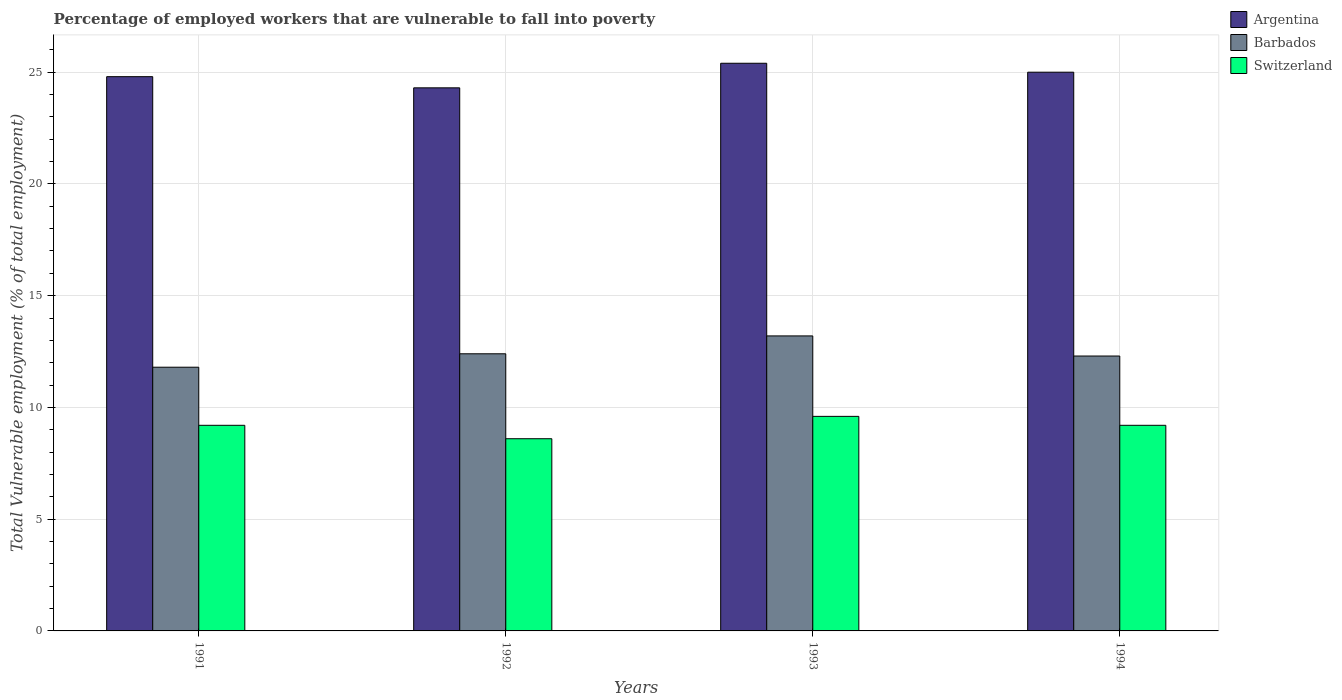How many different coloured bars are there?
Offer a very short reply. 3. Are the number of bars per tick equal to the number of legend labels?
Your response must be concise. Yes. Are the number of bars on each tick of the X-axis equal?
Your answer should be very brief. Yes. How many bars are there on the 3rd tick from the right?
Provide a succinct answer. 3. What is the label of the 2nd group of bars from the left?
Provide a short and direct response. 1992. What is the percentage of employed workers who are vulnerable to fall into poverty in Barbados in 1992?
Your answer should be compact. 12.4. Across all years, what is the maximum percentage of employed workers who are vulnerable to fall into poverty in Barbados?
Your response must be concise. 13.2. Across all years, what is the minimum percentage of employed workers who are vulnerable to fall into poverty in Switzerland?
Keep it short and to the point. 8.6. In which year was the percentage of employed workers who are vulnerable to fall into poverty in Argentina maximum?
Provide a succinct answer. 1993. What is the total percentage of employed workers who are vulnerable to fall into poverty in Argentina in the graph?
Keep it short and to the point. 99.5. What is the difference between the percentage of employed workers who are vulnerable to fall into poverty in Argentina in 1992 and that in 1993?
Your answer should be very brief. -1.1. What is the difference between the percentage of employed workers who are vulnerable to fall into poverty in Barbados in 1993 and the percentage of employed workers who are vulnerable to fall into poverty in Switzerland in 1994?
Provide a succinct answer. 4. What is the average percentage of employed workers who are vulnerable to fall into poverty in Argentina per year?
Your answer should be very brief. 24.87. In the year 1991, what is the difference between the percentage of employed workers who are vulnerable to fall into poverty in Switzerland and percentage of employed workers who are vulnerable to fall into poverty in Barbados?
Make the answer very short. -2.6. In how many years, is the percentage of employed workers who are vulnerable to fall into poverty in Barbados greater than 10 %?
Provide a short and direct response. 4. What is the ratio of the percentage of employed workers who are vulnerable to fall into poverty in Switzerland in 1992 to that in 1994?
Provide a short and direct response. 0.93. Is the percentage of employed workers who are vulnerable to fall into poverty in Switzerland in 1992 less than that in 1993?
Provide a short and direct response. Yes. Is the difference between the percentage of employed workers who are vulnerable to fall into poverty in Switzerland in 1991 and 1994 greater than the difference between the percentage of employed workers who are vulnerable to fall into poverty in Barbados in 1991 and 1994?
Make the answer very short. Yes. What is the difference between the highest and the second highest percentage of employed workers who are vulnerable to fall into poverty in Barbados?
Offer a terse response. 0.8. What is the difference between the highest and the lowest percentage of employed workers who are vulnerable to fall into poverty in Barbados?
Provide a succinct answer. 1.4. In how many years, is the percentage of employed workers who are vulnerable to fall into poverty in Barbados greater than the average percentage of employed workers who are vulnerable to fall into poverty in Barbados taken over all years?
Your response must be concise. 1. What does the 3rd bar from the left in 1993 represents?
Your answer should be compact. Switzerland. What does the 1st bar from the right in 1991 represents?
Your response must be concise. Switzerland. How many bars are there?
Make the answer very short. 12. Are all the bars in the graph horizontal?
Ensure brevity in your answer.  No. Does the graph contain any zero values?
Offer a very short reply. No. How many legend labels are there?
Your answer should be very brief. 3. What is the title of the graph?
Offer a very short reply. Percentage of employed workers that are vulnerable to fall into poverty. Does "Arab World" appear as one of the legend labels in the graph?
Provide a short and direct response. No. What is the label or title of the Y-axis?
Provide a succinct answer. Total Vulnerable employment (% of total employment). What is the Total Vulnerable employment (% of total employment) in Argentina in 1991?
Provide a succinct answer. 24.8. What is the Total Vulnerable employment (% of total employment) in Barbados in 1991?
Your answer should be very brief. 11.8. What is the Total Vulnerable employment (% of total employment) of Switzerland in 1991?
Offer a terse response. 9.2. What is the Total Vulnerable employment (% of total employment) in Argentina in 1992?
Ensure brevity in your answer.  24.3. What is the Total Vulnerable employment (% of total employment) of Barbados in 1992?
Make the answer very short. 12.4. What is the Total Vulnerable employment (% of total employment) of Switzerland in 1992?
Keep it short and to the point. 8.6. What is the Total Vulnerable employment (% of total employment) of Argentina in 1993?
Keep it short and to the point. 25.4. What is the Total Vulnerable employment (% of total employment) of Barbados in 1993?
Give a very brief answer. 13.2. What is the Total Vulnerable employment (% of total employment) in Switzerland in 1993?
Provide a short and direct response. 9.6. What is the Total Vulnerable employment (% of total employment) of Argentina in 1994?
Your answer should be compact. 25. What is the Total Vulnerable employment (% of total employment) of Barbados in 1994?
Your answer should be compact. 12.3. What is the Total Vulnerable employment (% of total employment) in Switzerland in 1994?
Your answer should be very brief. 9.2. Across all years, what is the maximum Total Vulnerable employment (% of total employment) of Argentina?
Your answer should be very brief. 25.4. Across all years, what is the maximum Total Vulnerable employment (% of total employment) of Barbados?
Provide a short and direct response. 13.2. Across all years, what is the maximum Total Vulnerable employment (% of total employment) in Switzerland?
Give a very brief answer. 9.6. Across all years, what is the minimum Total Vulnerable employment (% of total employment) in Argentina?
Your answer should be compact. 24.3. Across all years, what is the minimum Total Vulnerable employment (% of total employment) in Barbados?
Provide a succinct answer. 11.8. Across all years, what is the minimum Total Vulnerable employment (% of total employment) of Switzerland?
Provide a succinct answer. 8.6. What is the total Total Vulnerable employment (% of total employment) of Argentina in the graph?
Provide a short and direct response. 99.5. What is the total Total Vulnerable employment (% of total employment) of Barbados in the graph?
Your response must be concise. 49.7. What is the total Total Vulnerable employment (% of total employment) in Switzerland in the graph?
Provide a short and direct response. 36.6. What is the difference between the Total Vulnerable employment (% of total employment) in Switzerland in 1991 and that in 1992?
Keep it short and to the point. 0.6. What is the difference between the Total Vulnerable employment (% of total employment) in Switzerland in 1991 and that in 1993?
Provide a succinct answer. -0.4. What is the difference between the Total Vulnerable employment (% of total employment) in Argentina in 1991 and that in 1994?
Offer a terse response. -0.2. What is the difference between the Total Vulnerable employment (% of total employment) in Switzerland in 1991 and that in 1994?
Make the answer very short. 0. What is the difference between the Total Vulnerable employment (% of total employment) in Argentina in 1992 and that in 1993?
Your answer should be compact. -1.1. What is the difference between the Total Vulnerable employment (% of total employment) in Barbados in 1992 and that in 1993?
Make the answer very short. -0.8. What is the difference between the Total Vulnerable employment (% of total employment) in Switzerland in 1992 and that in 1993?
Your answer should be very brief. -1. What is the difference between the Total Vulnerable employment (% of total employment) of Barbados in 1992 and that in 1994?
Your answer should be compact. 0.1. What is the difference between the Total Vulnerable employment (% of total employment) in Switzerland in 1993 and that in 1994?
Make the answer very short. 0.4. What is the difference between the Total Vulnerable employment (% of total employment) of Argentina in 1991 and the Total Vulnerable employment (% of total employment) of Barbados in 1993?
Make the answer very short. 11.6. What is the difference between the Total Vulnerable employment (% of total employment) of Barbados in 1991 and the Total Vulnerable employment (% of total employment) of Switzerland in 1993?
Keep it short and to the point. 2.2. What is the difference between the Total Vulnerable employment (% of total employment) in Argentina in 1991 and the Total Vulnerable employment (% of total employment) in Barbados in 1994?
Your response must be concise. 12.5. What is the difference between the Total Vulnerable employment (% of total employment) in Argentina in 1992 and the Total Vulnerable employment (% of total employment) in Barbados in 1993?
Ensure brevity in your answer.  11.1. What is the difference between the Total Vulnerable employment (% of total employment) in Argentina in 1992 and the Total Vulnerable employment (% of total employment) in Switzerland in 1993?
Offer a very short reply. 14.7. What is the difference between the Total Vulnerable employment (% of total employment) in Barbados in 1992 and the Total Vulnerable employment (% of total employment) in Switzerland in 1993?
Keep it short and to the point. 2.8. What is the difference between the Total Vulnerable employment (% of total employment) in Argentina in 1993 and the Total Vulnerable employment (% of total employment) in Barbados in 1994?
Give a very brief answer. 13.1. What is the difference between the Total Vulnerable employment (% of total employment) in Barbados in 1993 and the Total Vulnerable employment (% of total employment) in Switzerland in 1994?
Your answer should be very brief. 4. What is the average Total Vulnerable employment (% of total employment) of Argentina per year?
Your answer should be compact. 24.88. What is the average Total Vulnerable employment (% of total employment) in Barbados per year?
Your answer should be very brief. 12.43. What is the average Total Vulnerable employment (% of total employment) of Switzerland per year?
Provide a succinct answer. 9.15. In the year 1991, what is the difference between the Total Vulnerable employment (% of total employment) in Barbados and Total Vulnerable employment (% of total employment) in Switzerland?
Give a very brief answer. 2.6. What is the ratio of the Total Vulnerable employment (% of total employment) in Argentina in 1991 to that in 1992?
Offer a very short reply. 1.02. What is the ratio of the Total Vulnerable employment (% of total employment) of Barbados in 1991 to that in 1992?
Ensure brevity in your answer.  0.95. What is the ratio of the Total Vulnerable employment (% of total employment) of Switzerland in 1991 to that in 1992?
Your response must be concise. 1.07. What is the ratio of the Total Vulnerable employment (% of total employment) in Argentina in 1991 to that in 1993?
Give a very brief answer. 0.98. What is the ratio of the Total Vulnerable employment (% of total employment) in Barbados in 1991 to that in 1993?
Provide a succinct answer. 0.89. What is the ratio of the Total Vulnerable employment (% of total employment) of Switzerland in 1991 to that in 1993?
Offer a terse response. 0.96. What is the ratio of the Total Vulnerable employment (% of total employment) of Barbados in 1991 to that in 1994?
Keep it short and to the point. 0.96. What is the ratio of the Total Vulnerable employment (% of total employment) of Switzerland in 1991 to that in 1994?
Make the answer very short. 1. What is the ratio of the Total Vulnerable employment (% of total employment) of Argentina in 1992 to that in 1993?
Offer a terse response. 0.96. What is the ratio of the Total Vulnerable employment (% of total employment) of Barbados in 1992 to that in 1993?
Provide a short and direct response. 0.94. What is the ratio of the Total Vulnerable employment (% of total employment) in Switzerland in 1992 to that in 1993?
Ensure brevity in your answer.  0.9. What is the ratio of the Total Vulnerable employment (% of total employment) in Switzerland in 1992 to that in 1994?
Offer a very short reply. 0.93. What is the ratio of the Total Vulnerable employment (% of total employment) in Barbados in 1993 to that in 1994?
Make the answer very short. 1.07. What is the ratio of the Total Vulnerable employment (% of total employment) in Switzerland in 1993 to that in 1994?
Provide a succinct answer. 1.04. What is the difference between the highest and the second highest Total Vulnerable employment (% of total employment) in Barbados?
Keep it short and to the point. 0.8. What is the difference between the highest and the lowest Total Vulnerable employment (% of total employment) of Argentina?
Your answer should be compact. 1.1. What is the difference between the highest and the lowest Total Vulnerable employment (% of total employment) of Barbados?
Ensure brevity in your answer.  1.4. 